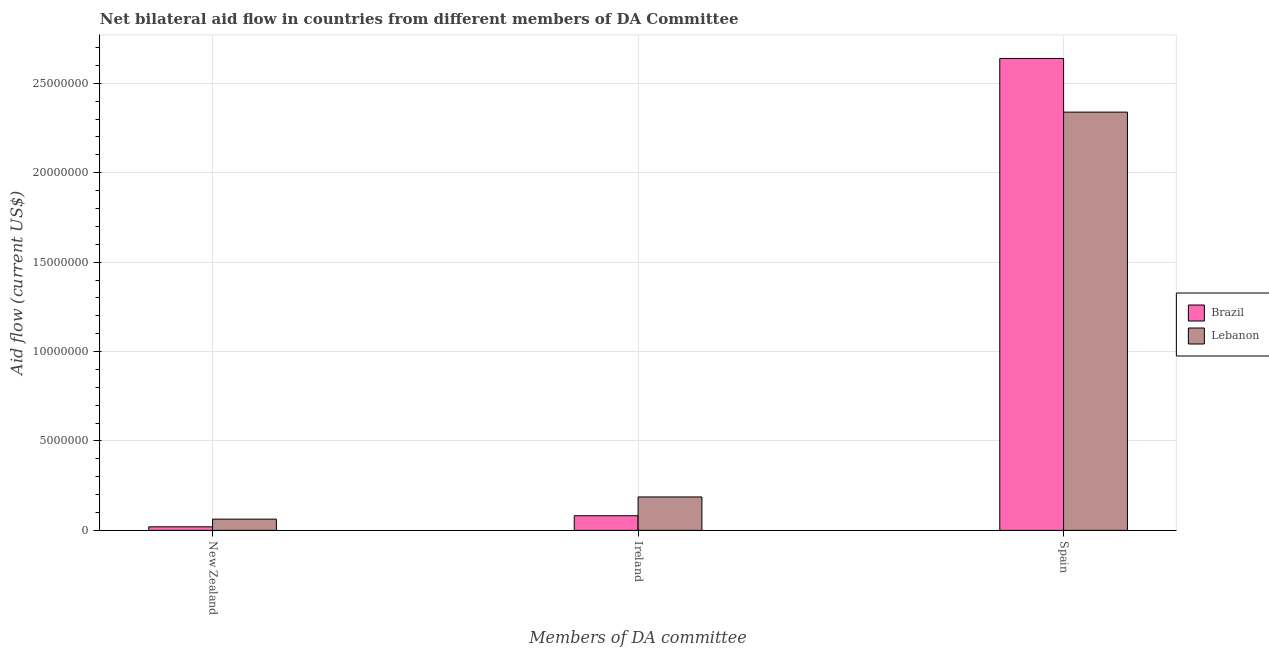How many different coloured bars are there?
Make the answer very short. 2. Are the number of bars per tick equal to the number of legend labels?
Provide a short and direct response. Yes. Are the number of bars on each tick of the X-axis equal?
Make the answer very short. Yes. What is the label of the 1st group of bars from the left?
Offer a terse response. New Zealand. What is the amount of aid provided by new zealand in Lebanon?
Your response must be concise. 6.30e+05. Across all countries, what is the maximum amount of aid provided by ireland?
Give a very brief answer. 1.87e+06. Across all countries, what is the minimum amount of aid provided by new zealand?
Offer a terse response. 2.00e+05. In which country was the amount of aid provided by ireland maximum?
Your answer should be very brief. Lebanon. In which country was the amount of aid provided by spain minimum?
Offer a very short reply. Lebanon. What is the total amount of aid provided by new zealand in the graph?
Your answer should be very brief. 8.30e+05. What is the difference between the amount of aid provided by new zealand in Lebanon and that in Brazil?
Offer a terse response. 4.30e+05. What is the difference between the amount of aid provided by spain in Lebanon and the amount of aid provided by new zealand in Brazil?
Ensure brevity in your answer.  2.32e+07. What is the average amount of aid provided by new zealand per country?
Give a very brief answer. 4.15e+05. What is the difference between the amount of aid provided by ireland and amount of aid provided by new zealand in Lebanon?
Your answer should be very brief. 1.24e+06. In how many countries, is the amount of aid provided by spain greater than 10000000 US$?
Provide a succinct answer. 2. What is the ratio of the amount of aid provided by new zealand in Brazil to that in Lebanon?
Your answer should be compact. 0.32. What is the difference between the highest and the second highest amount of aid provided by new zealand?
Your response must be concise. 4.30e+05. What is the difference between the highest and the lowest amount of aid provided by ireland?
Provide a short and direct response. 1.05e+06. What does the 2nd bar from the right in New Zealand represents?
Your answer should be very brief. Brazil. Is it the case that in every country, the sum of the amount of aid provided by new zealand and amount of aid provided by ireland is greater than the amount of aid provided by spain?
Provide a succinct answer. No. Are all the bars in the graph horizontal?
Make the answer very short. No. How many countries are there in the graph?
Offer a terse response. 2. What is the difference between two consecutive major ticks on the Y-axis?
Your answer should be very brief. 5.00e+06. Are the values on the major ticks of Y-axis written in scientific E-notation?
Your answer should be compact. No. Does the graph contain any zero values?
Provide a short and direct response. No. Where does the legend appear in the graph?
Provide a succinct answer. Center right. How are the legend labels stacked?
Make the answer very short. Vertical. What is the title of the graph?
Give a very brief answer. Net bilateral aid flow in countries from different members of DA Committee. What is the label or title of the X-axis?
Your answer should be very brief. Members of DA committee. What is the label or title of the Y-axis?
Provide a succinct answer. Aid flow (current US$). What is the Aid flow (current US$) in Lebanon in New Zealand?
Keep it short and to the point. 6.30e+05. What is the Aid flow (current US$) in Brazil in Ireland?
Ensure brevity in your answer.  8.20e+05. What is the Aid flow (current US$) of Lebanon in Ireland?
Your response must be concise. 1.87e+06. What is the Aid flow (current US$) of Brazil in Spain?
Provide a succinct answer. 2.64e+07. What is the Aid flow (current US$) of Lebanon in Spain?
Provide a short and direct response. 2.34e+07. Across all Members of DA committee, what is the maximum Aid flow (current US$) of Brazil?
Keep it short and to the point. 2.64e+07. Across all Members of DA committee, what is the maximum Aid flow (current US$) of Lebanon?
Make the answer very short. 2.34e+07. Across all Members of DA committee, what is the minimum Aid flow (current US$) in Brazil?
Provide a short and direct response. 2.00e+05. Across all Members of DA committee, what is the minimum Aid flow (current US$) in Lebanon?
Provide a succinct answer. 6.30e+05. What is the total Aid flow (current US$) in Brazil in the graph?
Give a very brief answer. 2.74e+07. What is the total Aid flow (current US$) of Lebanon in the graph?
Offer a terse response. 2.59e+07. What is the difference between the Aid flow (current US$) in Brazil in New Zealand and that in Ireland?
Ensure brevity in your answer.  -6.20e+05. What is the difference between the Aid flow (current US$) of Lebanon in New Zealand and that in Ireland?
Provide a succinct answer. -1.24e+06. What is the difference between the Aid flow (current US$) in Brazil in New Zealand and that in Spain?
Your answer should be compact. -2.62e+07. What is the difference between the Aid flow (current US$) of Lebanon in New Zealand and that in Spain?
Provide a short and direct response. -2.28e+07. What is the difference between the Aid flow (current US$) in Brazil in Ireland and that in Spain?
Offer a very short reply. -2.56e+07. What is the difference between the Aid flow (current US$) in Lebanon in Ireland and that in Spain?
Keep it short and to the point. -2.15e+07. What is the difference between the Aid flow (current US$) of Brazil in New Zealand and the Aid flow (current US$) of Lebanon in Ireland?
Make the answer very short. -1.67e+06. What is the difference between the Aid flow (current US$) of Brazil in New Zealand and the Aid flow (current US$) of Lebanon in Spain?
Give a very brief answer. -2.32e+07. What is the difference between the Aid flow (current US$) of Brazil in Ireland and the Aid flow (current US$) of Lebanon in Spain?
Keep it short and to the point. -2.26e+07. What is the average Aid flow (current US$) of Brazil per Members of DA committee?
Ensure brevity in your answer.  9.14e+06. What is the average Aid flow (current US$) of Lebanon per Members of DA committee?
Offer a very short reply. 8.63e+06. What is the difference between the Aid flow (current US$) in Brazil and Aid flow (current US$) in Lebanon in New Zealand?
Your answer should be compact. -4.30e+05. What is the difference between the Aid flow (current US$) of Brazil and Aid flow (current US$) of Lebanon in Ireland?
Your response must be concise. -1.05e+06. What is the difference between the Aid flow (current US$) of Brazil and Aid flow (current US$) of Lebanon in Spain?
Keep it short and to the point. 3.00e+06. What is the ratio of the Aid flow (current US$) in Brazil in New Zealand to that in Ireland?
Offer a terse response. 0.24. What is the ratio of the Aid flow (current US$) in Lebanon in New Zealand to that in Ireland?
Offer a terse response. 0.34. What is the ratio of the Aid flow (current US$) of Brazil in New Zealand to that in Spain?
Offer a terse response. 0.01. What is the ratio of the Aid flow (current US$) of Lebanon in New Zealand to that in Spain?
Give a very brief answer. 0.03. What is the ratio of the Aid flow (current US$) in Brazil in Ireland to that in Spain?
Make the answer very short. 0.03. What is the ratio of the Aid flow (current US$) of Lebanon in Ireland to that in Spain?
Offer a very short reply. 0.08. What is the difference between the highest and the second highest Aid flow (current US$) of Brazil?
Give a very brief answer. 2.56e+07. What is the difference between the highest and the second highest Aid flow (current US$) of Lebanon?
Ensure brevity in your answer.  2.15e+07. What is the difference between the highest and the lowest Aid flow (current US$) in Brazil?
Offer a terse response. 2.62e+07. What is the difference between the highest and the lowest Aid flow (current US$) in Lebanon?
Your response must be concise. 2.28e+07. 